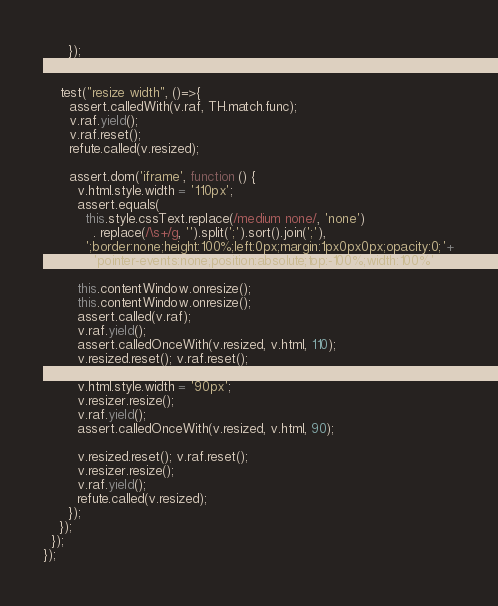Convert code to text. <code><loc_0><loc_0><loc_500><loc_500><_JavaScript_>      });
    });

    test("resize width", ()=>{
      assert.calledWith(v.raf, TH.match.func);
      v.raf.yield();
      v.raf.reset();
      refute.called(v.resized);

      assert.dom('iframe', function () {
        v.html.style.width = '110px';
        assert.equals(
          this.style.cssText.replace(/medium none/, 'none')
            . replace(/\s+/g, '').split(';').sort().join(';'),
          ';border:none;height:100%;left:0px;margin:1px0px0px;opacity:0;'+
            'pointer-events:none;position:absolute;top:-100%;width:100%');

        this.contentWindow.onresize();
        this.contentWindow.onresize();
        assert.called(v.raf);
        v.raf.yield();
        assert.calledOnceWith(v.resized, v.html, 110);
        v.resized.reset(); v.raf.reset();

        v.html.style.width = '90px';
        v.resizer.resize();
        v.raf.yield();
        assert.calledOnceWith(v.resized, v.html, 90);

        v.resized.reset(); v.raf.reset();
        v.resizer.resize();
        v.raf.yield();
        refute.called(v.resized);
      });
    });
  });
});
</code> 